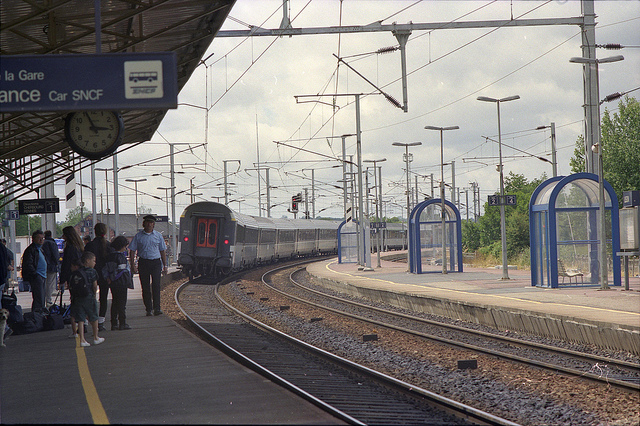Please transcribe the text in this image. Gare ance Car SNCF la 